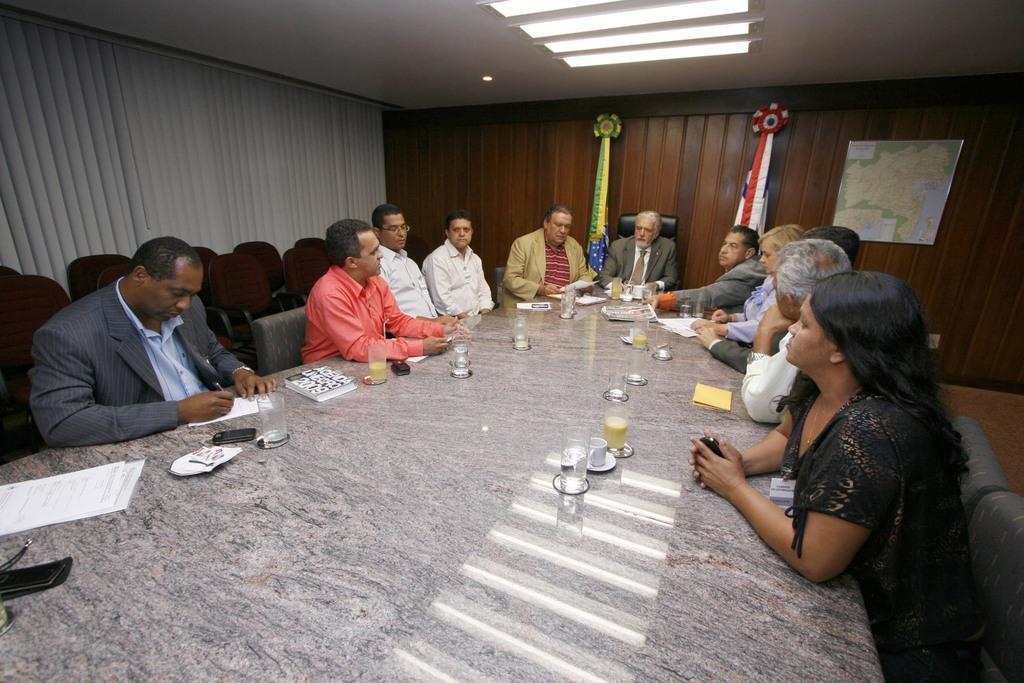Please provide a concise description of this image. This picture is clicked inside the room which may be a Conference room which includes group of people, many number of chairs and a table. There are some papers, some books, a glass of water, a glass of juice, cup with a saucer, and a mobile phone placed on the top of the table. On the right there is a group of five persons sitting on the chairs. In the center there is a group of five men sitting on the chairs. On the left there is a Man wearing suit and sitting on the chair, writing with a pen on a paper. In the background there is a wooden wall on which we can see two decorated ribbons and one map mounted on the wall. 